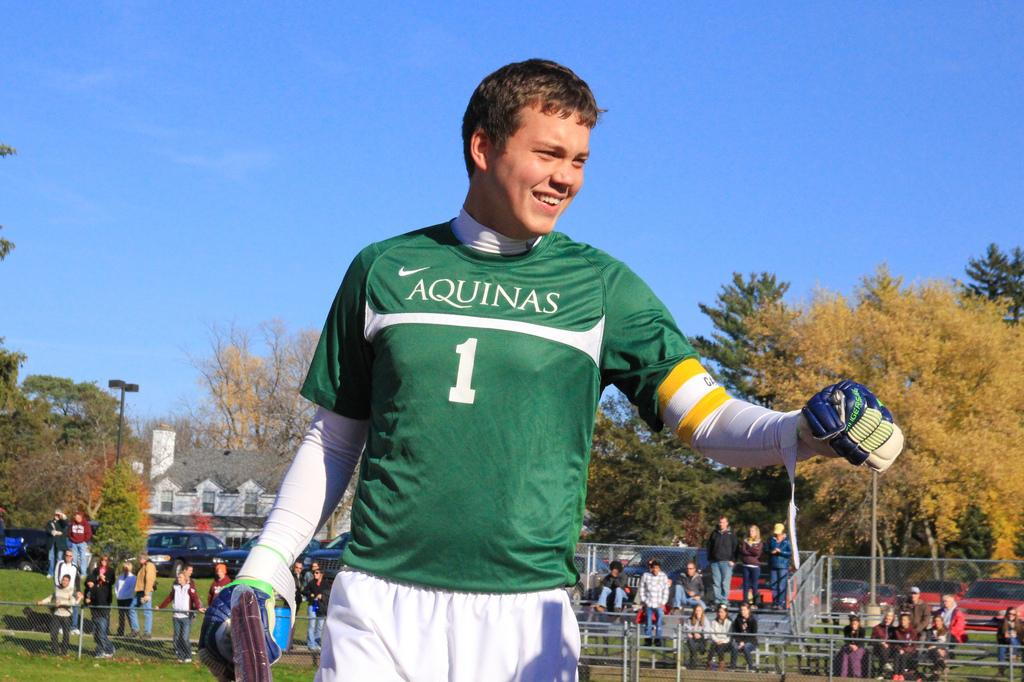<image>
Write a terse but informative summary of the picture. A man wearing a green Aquinas jersey with the number 1. 